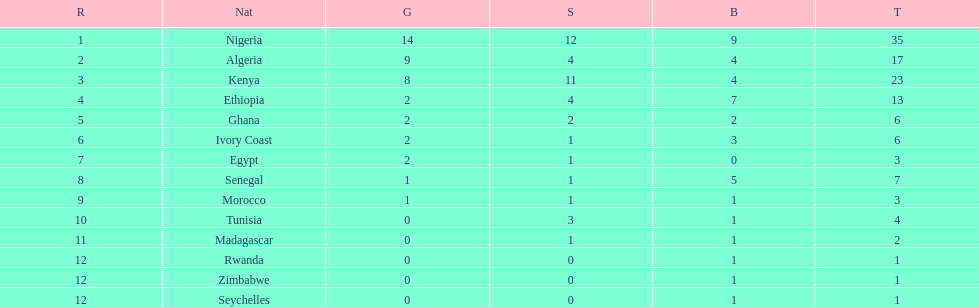The country that won the most medals was? Nigeria. 